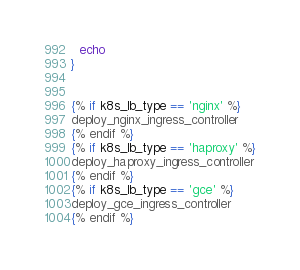Convert code to text. <code><loc_0><loc_0><loc_500><loc_500><_Bash_>  echo
}


{% if k8s_lb_type == 'nginx' %}
deploy_nginx_ingress_controller
{% endif %}
{% if k8s_lb_type == 'haproxy' %}
deploy_haproxy_ingress_controller
{% endif %}
{% if k8s_lb_type == 'gce' %}
deploy_gce_ingress_controller
{% endif %}
</code> 